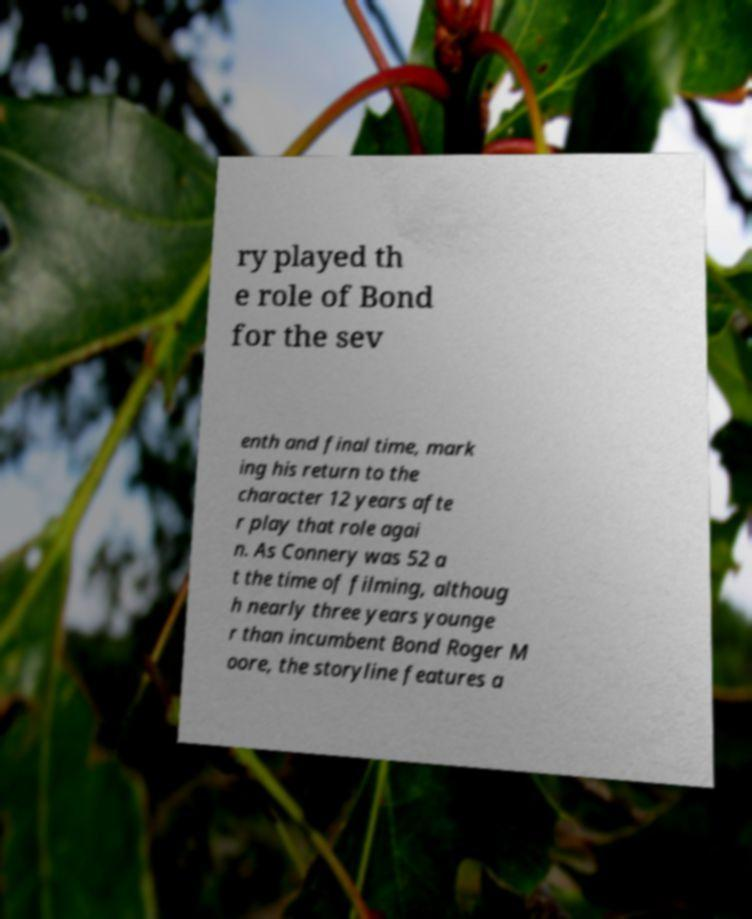Can you accurately transcribe the text from the provided image for me? ry played th e role of Bond for the sev enth and final time, mark ing his return to the character 12 years afte r play that role agai n. As Connery was 52 a t the time of filming, althoug h nearly three years younge r than incumbent Bond Roger M oore, the storyline features a 